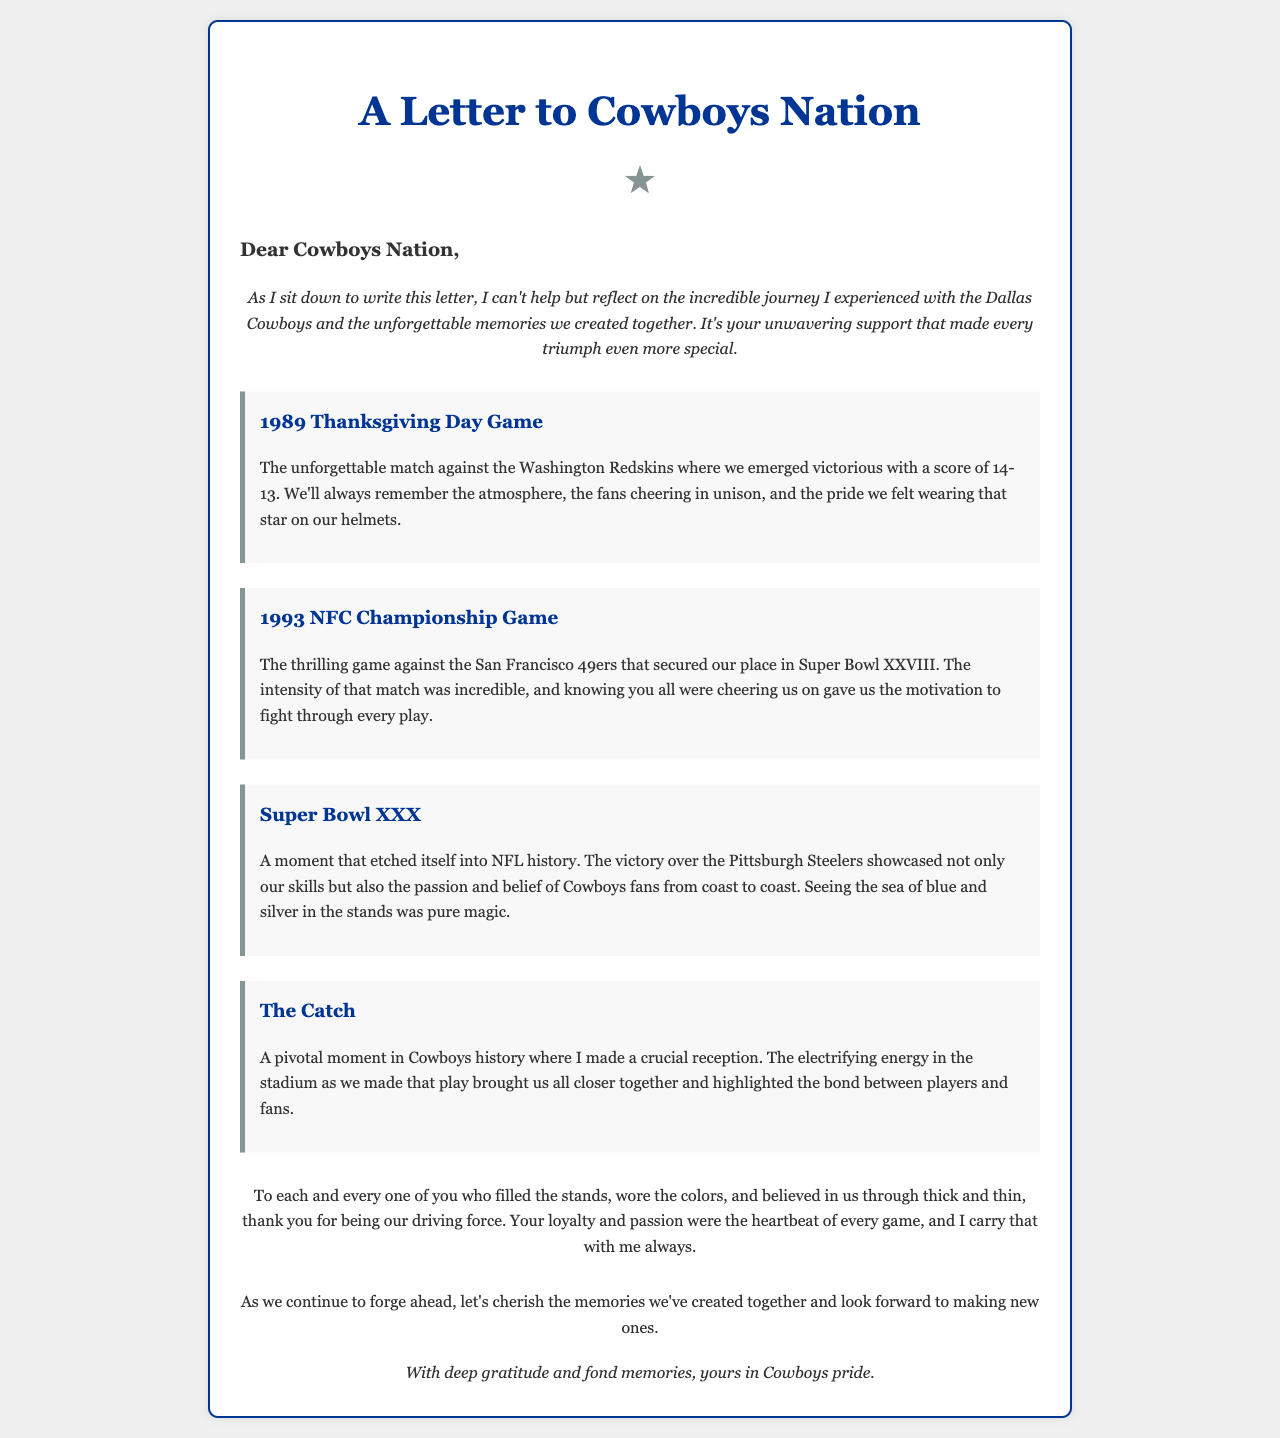What game is mentioned in the 1989 moment? The document details the 1989 Thanksgiving Day Game against the Washington Redskins.
Answer: Thanksgiving Day Game What was the score of the 1989 Thanksgiving Day Game? The document states the score was 14-13.
Answer: 14-13 Which game secured the Cowboys' place in Super Bowl XXVIII? The document mentions the 1993 NFC Championship Game against the San Francisco 49ers.
Answer: 1993 NFC Championship Game What victory is celebrated in Super Bowl XXX? The document refers to the Cowboys' victory over the Pittsburgh Steelers.
Answer: Pittsburgh Steelers What pivotal play is highlighted as "The Catch"? The letter discusses a crucial reception made by the author, which is termed "The Catch."
Answer: crucial reception What sentiment is expressed towards the fans in the appreciation section? The document expresses gratitude for the fans' loyalty and passion.
Answer: gratitude How does the letter conclude? The conclusion reflects on cherishing past memories and looking forward to new ones.
Answer: cherish the memories What is the overall tone of the letter? The letter conveys a tone of nostalgia and gratitude for support from fans.
Answer: nostalgic and grateful In what year did the Super Bowl XXX take place? The document notes that Super Bowl XXX was referenced, but the year isn't explicitly stated; it's known historically.
Answer: 1995 (historical knowledge) 